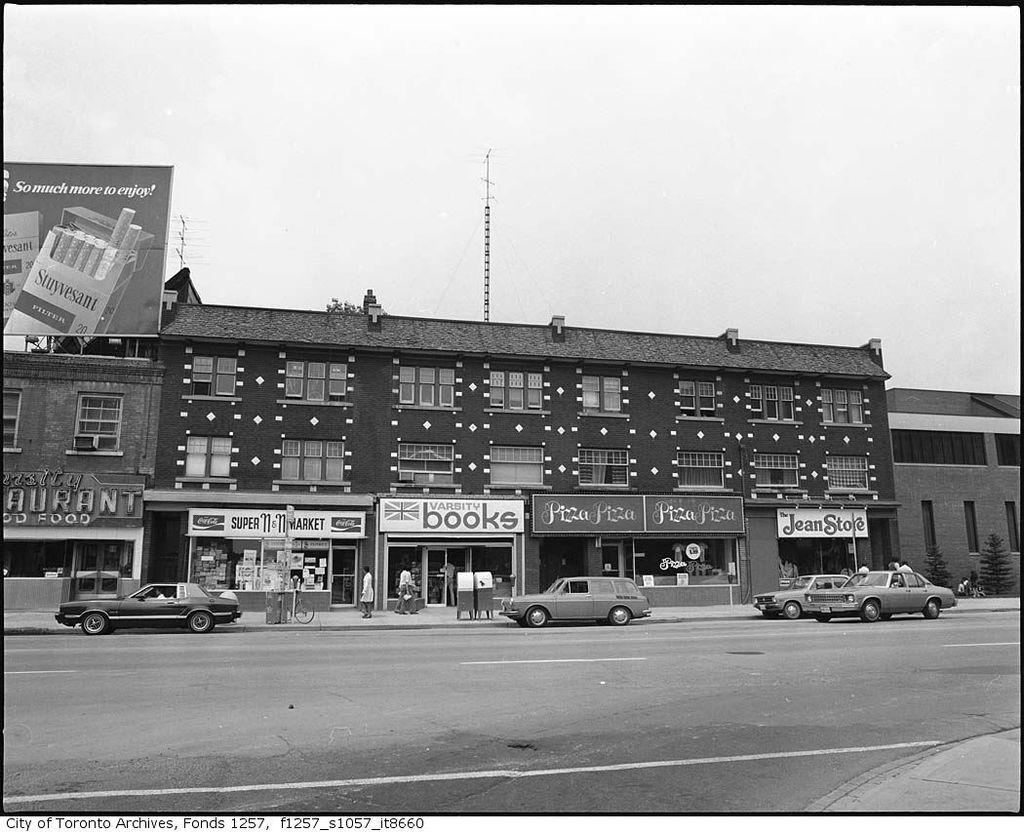What is the main feature of the image? There is a road in the image. What is happening on the road? There are cars on the road. Are there any buildings visible in the image? Yes, there is a house and shops in the image. What is visible at the top of the image? The sky is visible at the top of the image, and its color is white. What type of decision can be seen being made by the insect in the image? There are no insects present in the image, so no decision-making can be observed. 